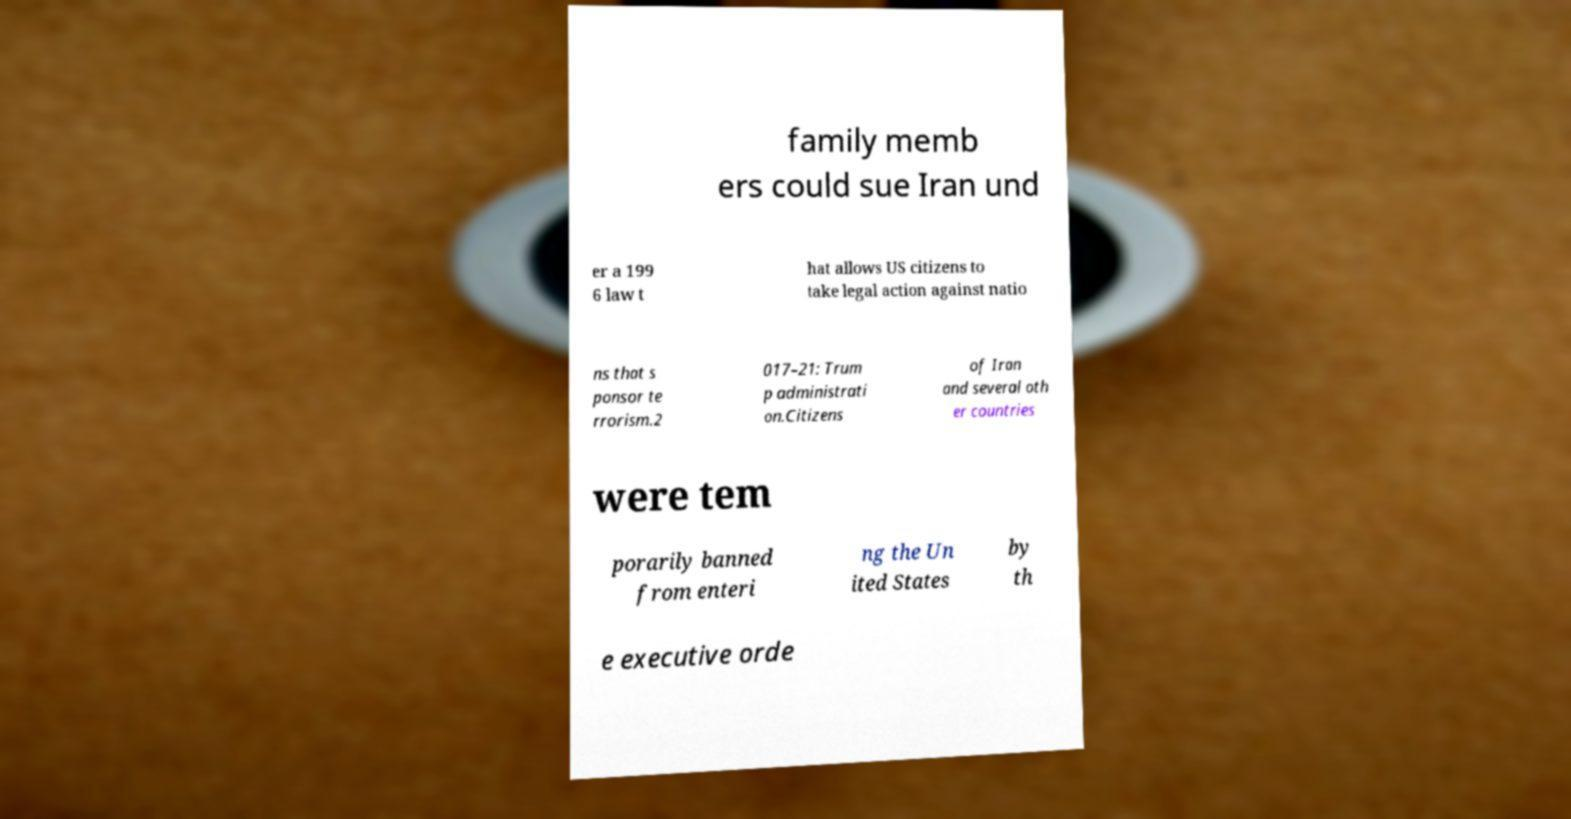For documentation purposes, I need the text within this image transcribed. Could you provide that? family memb ers could sue Iran und er a 199 6 law t hat allows US citizens to take legal action against natio ns that s ponsor te rrorism.2 017–21: Trum p administrati on.Citizens of Iran and several oth er countries were tem porarily banned from enteri ng the Un ited States by th e executive orde 